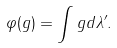<formula> <loc_0><loc_0><loc_500><loc_500>\varphi ( g ) = \int g d \lambda ^ { \prime } .</formula> 